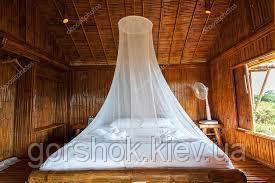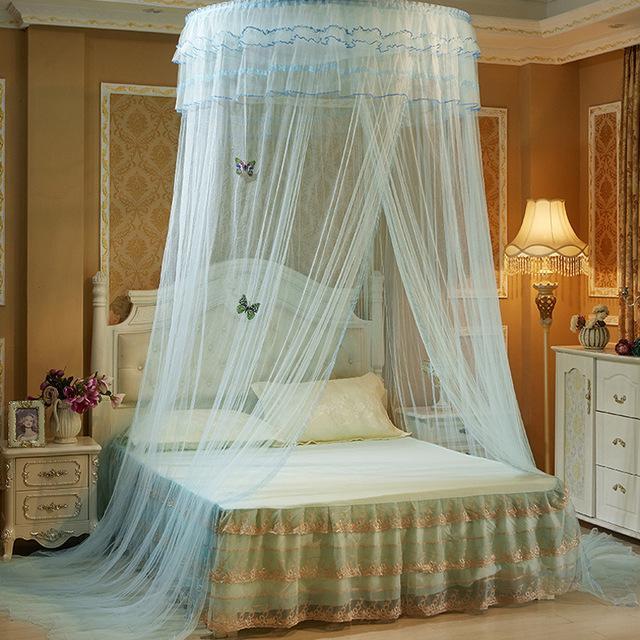The first image is the image on the left, the second image is the image on the right. Evaluate the accuracy of this statement regarding the images: "One image shows a gauzy pale canopy that drapes a bed from a round shape suspended from the ceiling, and the other image shows a canopy suspended from four corners.". Is it true? Answer yes or no. No. The first image is the image on the left, the second image is the image on the right. Examine the images to the left and right. Is the description "There is a round canopy bed in the right image." accurate? Answer yes or no. Yes. 